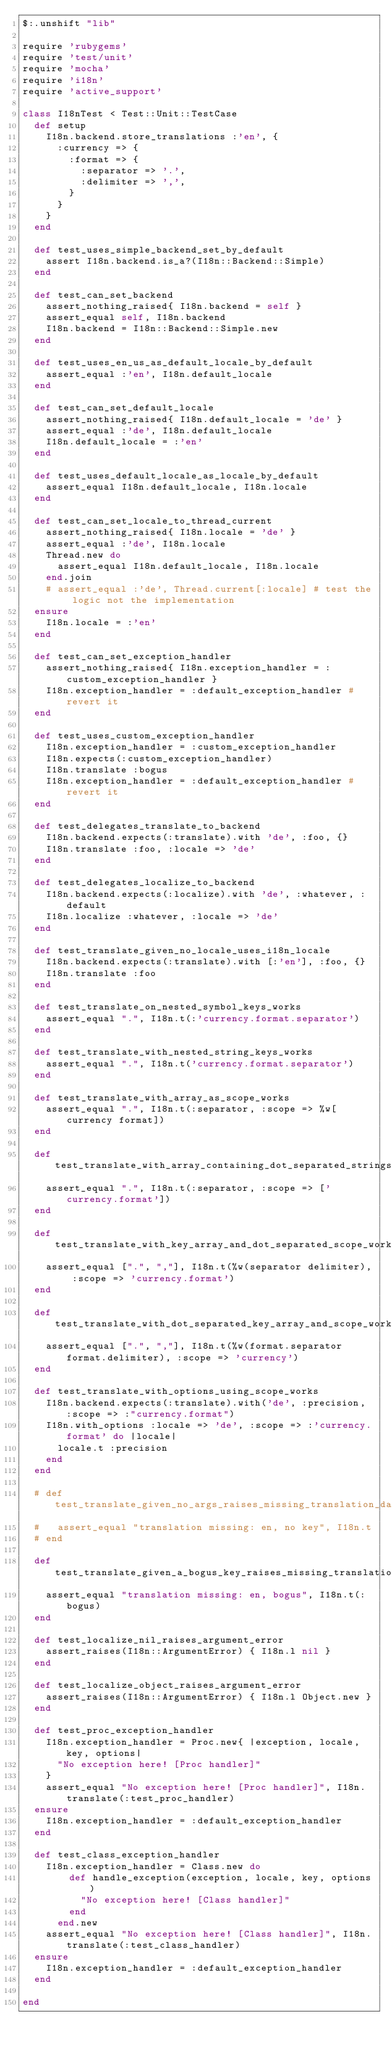Convert code to text. <code><loc_0><loc_0><loc_500><loc_500><_Ruby_>$:.unshift "lib"

require 'rubygems'
require 'test/unit'
require 'mocha'
require 'i18n'
require 'active_support'

class I18nTest < Test::Unit::TestCase
  def setup
    I18n.backend.store_translations :'en', {
      :currency => {
        :format => {
          :separator => '.',
          :delimiter => ',',
        }
      }
    }
  end

  def test_uses_simple_backend_set_by_default
    assert I18n.backend.is_a?(I18n::Backend::Simple)
  end

  def test_can_set_backend
    assert_nothing_raised{ I18n.backend = self }
    assert_equal self, I18n.backend
    I18n.backend = I18n::Backend::Simple.new
  end

  def test_uses_en_us_as_default_locale_by_default
    assert_equal :'en', I18n.default_locale
  end

  def test_can_set_default_locale
    assert_nothing_raised{ I18n.default_locale = 'de' }
    assert_equal :'de', I18n.default_locale
    I18n.default_locale = :'en'
  end

  def test_uses_default_locale_as_locale_by_default
    assert_equal I18n.default_locale, I18n.locale
  end

  def test_can_set_locale_to_thread_current
    assert_nothing_raised{ I18n.locale = 'de' }
    assert_equal :'de', I18n.locale
    Thread.new do
      assert_equal I18n.default_locale, I18n.locale
    end.join
    # assert_equal :'de', Thread.current[:locale] # test the logic not the implementation
  ensure
    I18n.locale = :'en'
  end

  def test_can_set_exception_handler
    assert_nothing_raised{ I18n.exception_handler = :custom_exception_handler }
    I18n.exception_handler = :default_exception_handler # revert it
  end

  def test_uses_custom_exception_handler
    I18n.exception_handler = :custom_exception_handler
    I18n.expects(:custom_exception_handler)
    I18n.translate :bogus
    I18n.exception_handler = :default_exception_handler # revert it
  end

  def test_delegates_translate_to_backend
    I18n.backend.expects(:translate).with 'de', :foo, {}
    I18n.translate :foo, :locale => 'de'
  end

  def test_delegates_localize_to_backend
    I18n.backend.expects(:localize).with 'de', :whatever, :default
    I18n.localize :whatever, :locale => 'de'
  end

  def test_translate_given_no_locale_uses_i18n_locale
    I18n.backend.expects(:translate).with [:'en'], :foo, {}
    I18n.translate :foo
  end

  def test_translate_on_nested_symbol_keys_works
    assert_equal ".", I18n.t(:'currency.format.separator')
  end

  def test_translate_with_nested_string_keys_works
    assert_equal ".", I18n.t('currency.format.separator')
  end

  def test_translate_with_array_as_scope_works
    assert_equal ".", I18n.t(:separator, :scope => %w[currency format])
  end

  def test_translate_with_array_containing_dot_separated_strings_as_scope_works
    assert_equal ".", I18n.t(:separator, :scope => ['currency.format'])
  end

  def test_translate_with_key_array_and_dot_separated_scope_works
    assert_equal [".", ","], I18n.t(%w(separator delimiter), :scope => 'currency.format')
  end

  def test_translate_with_dot_separated_key_array_and_scope_works
    assert_equal [".", ","], I18n.t(%w(format.separator format.delimiter), :scope => 'currency')
  end

  def test_translate_with_options_using_scope_works
    I18n.backend.expects(:translate).with('de', :precision, :scope => :"currency.format")
    I18n.with_options :locale => 'de', :scope => :'currency.format' do |locale|
      locale.t :precision
    end
  end

  # def test_translate_given_no_args_raises_missing_translation_data
  #   assert_equal "translation missing: en, no key", I18n.t
  # end

  def test_translate_given_a_bogus_key_raises_missing_translation_data
    assert_equal "translation missing: en, bogus", I18n.t(:bogus)
  end

  def test_localize_nil_raises_argument_error
    assert_raises(I18n::ArgumentError) { I18n.l nil }
  end

  def test_localize_object_raises_argument_error
    assert_raises(I18n::ArgumentError) { I18n.l Object.new }
  end

  def test_proc_exception_handler
    I18n.exception_handler = Proc.new{ |exception, locale, key, options|
      "No exception here! [Proc handler]"
    }
    assert_equal "No exception here! [Proc handler]", I18n.translate(:test_proc_handler)
  ensure
    I18n.exception_handler = :default_exception_handler
  end

  def test_class_exception_handler
    I18n.exception_handler = Class.new do
        def handle_exception(exception, locale, key, options)
          "No exception here! [Class handler]"
        end
      end.new
    assert_equal "No exception here! [Class handler]", I18n.translate(:test_class_handler)
  ensure
    I18n.exception_handler = :default_exception_handler
  end

end
</code> 